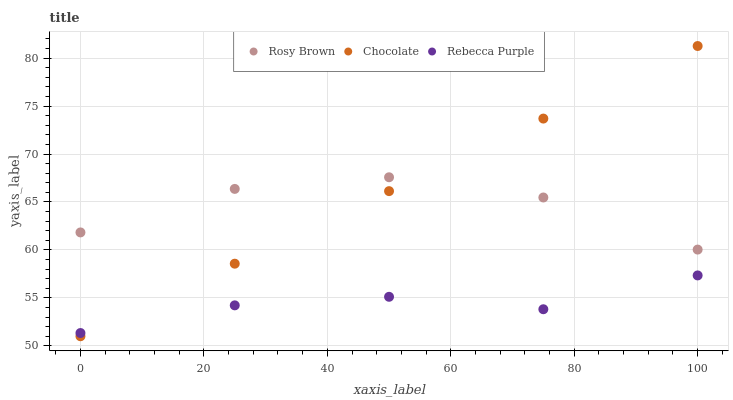Does Rebecca Purple have the minimum area under the curve?
Answer yes or no. Yes. Does Chocolate have the maximum area under the curve?
Answer yes or no. Yes. Does Chocolate have the minimum area under the curve?
Answer yes or no. No. Does Rebecca Purple have the maximum area under the curve?
Answer yes or no. No. Is Chocolate the smoothest?
Answer yes or no. Yes. Is Rosy Brown the roughest?
Answer yes or no. Yes. Is Rebecca Purple the smoothest?
Answer yes or no. No. Is Rebecca Purple the roughest?
Answer yes or no. No. Does Chocolate have the lowest value?
Answer yes or no. Yes. Does Rebecca Purple have the lowest value?
Answer yes or no. No. Does Chocolate have the highest value?
Answer yes or no. Yes. Does Rebecca Purple have the highest value?
Answer yes or no. No. Is Rebecca Purple less than Rosy Brown?
Answer yes or no. Yes. Is Rosy Brown greater than Rebecca Purple?
Answer yes or no. Yes. Does Chocolate intersect Rosy Brown?
Answer yes or no. Yes. Is Chocolate less than Rosy Brown?
Answer yes or no. No. Is Chocolate greater than Rosy Brown?
Answer yes or no. No. Does Rebecca Purple intersect Rosy Brown?
Answer yes or no. No. 